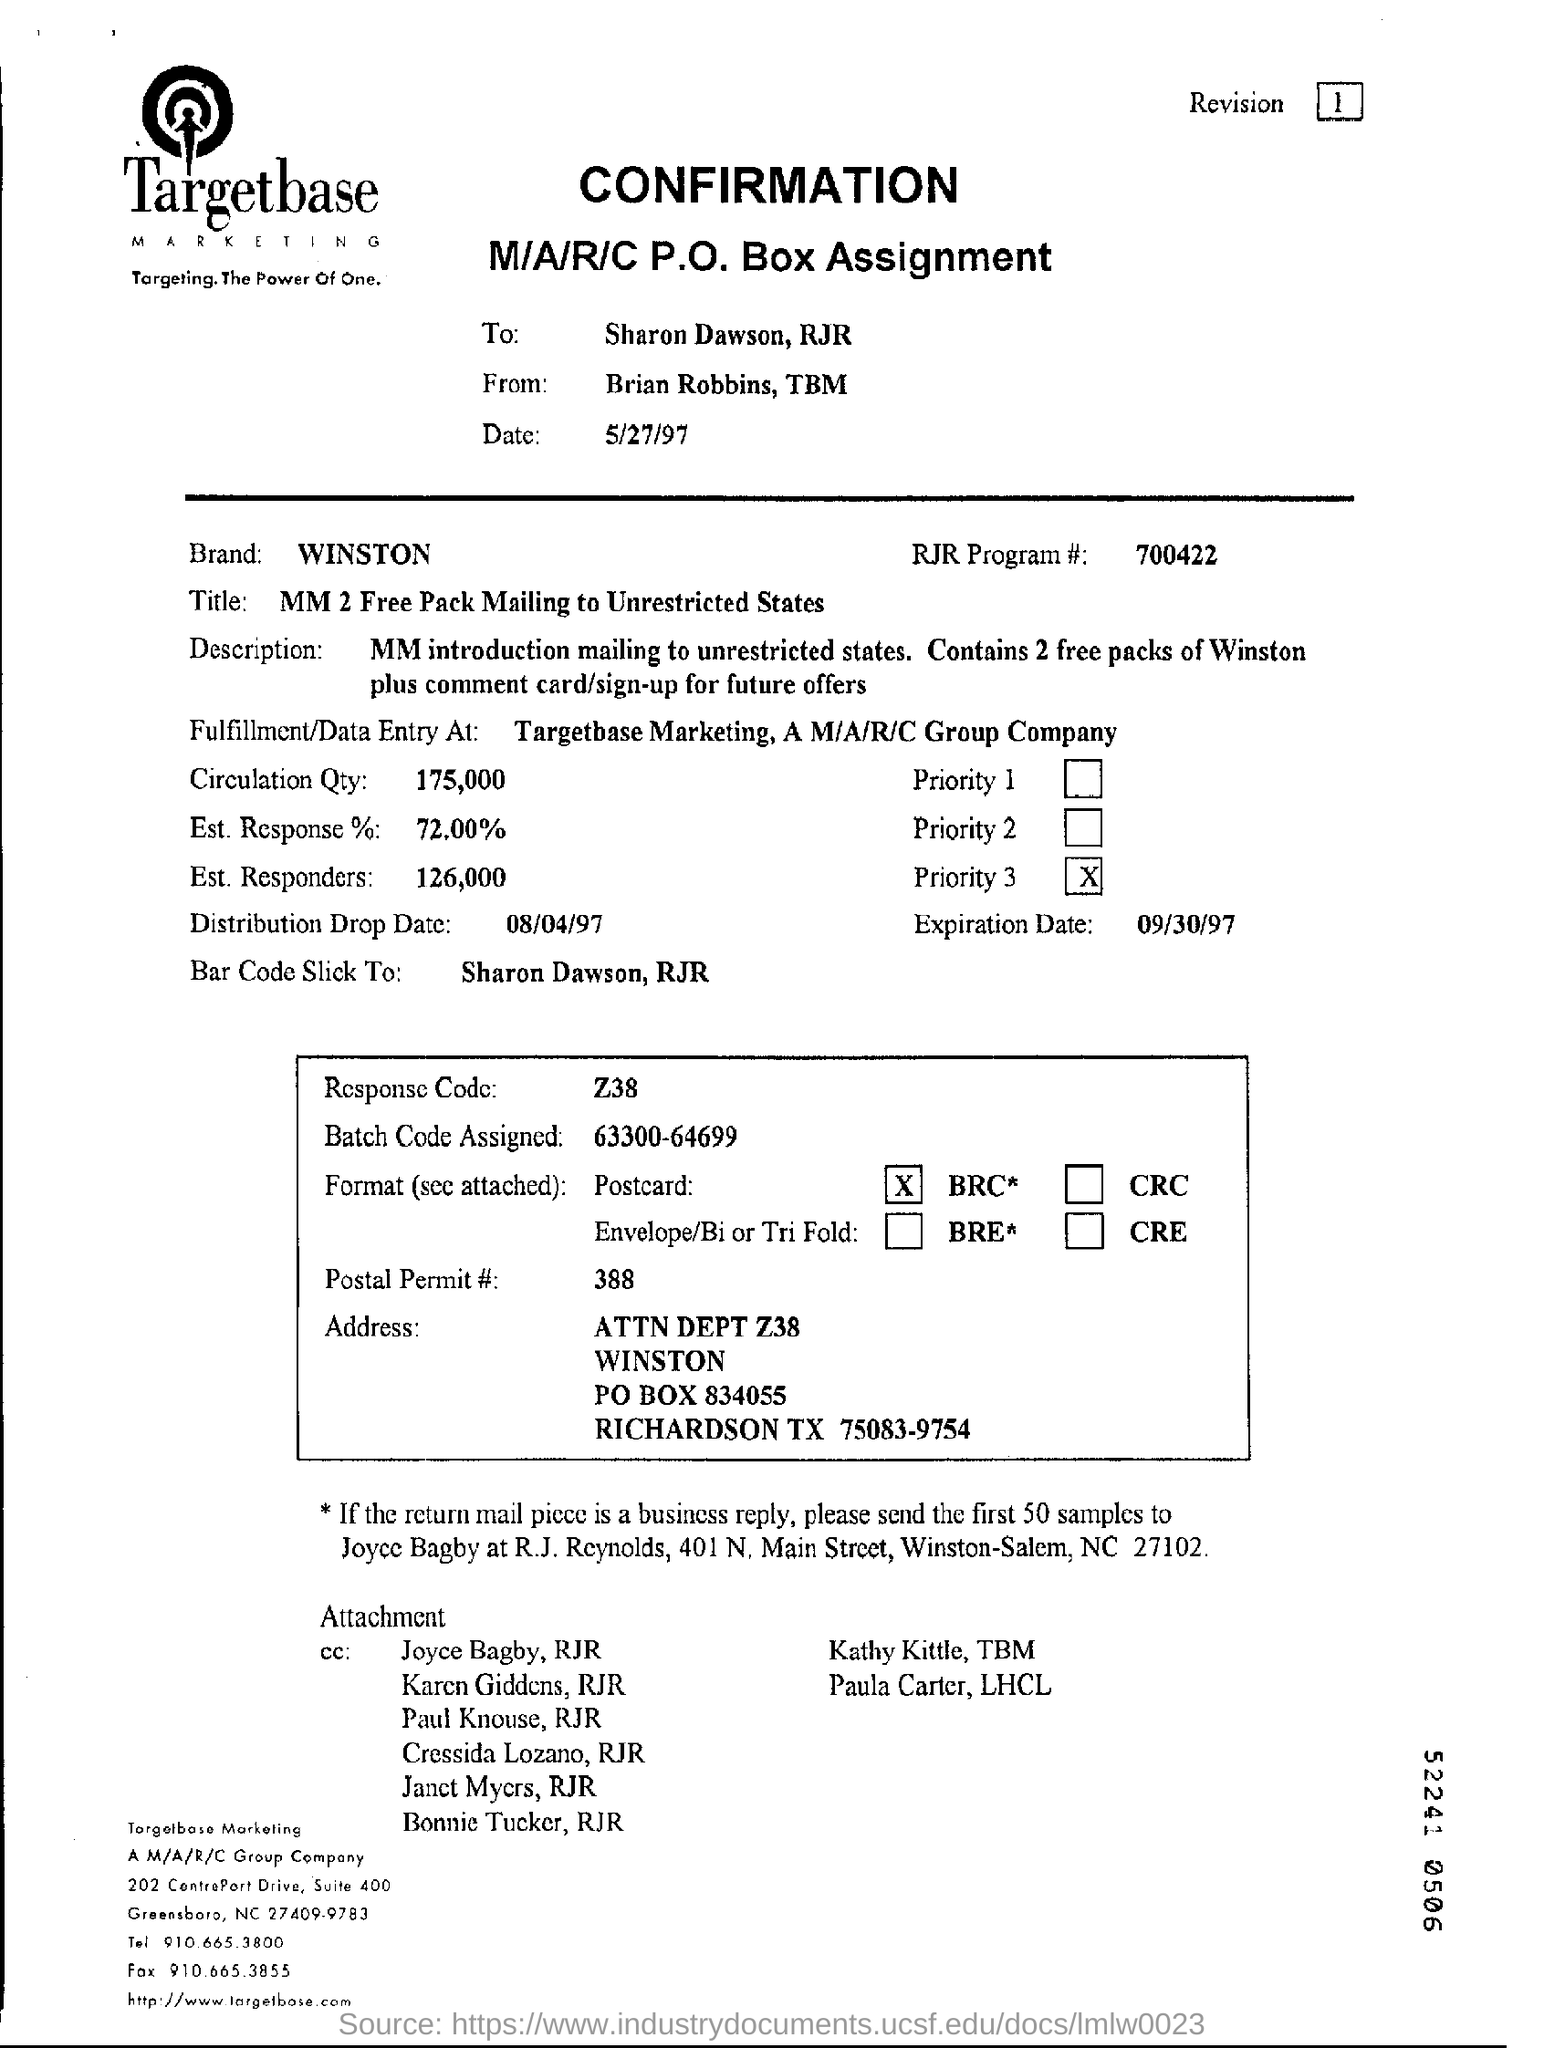What is the percentage of "Est.response" ?
Make the answer very short. 72.00. What is the quantity of circulation ?
Make the answer very short. 175,000. What is the date of confirmation ?
Provide a short and direct response. 5/27/97. What is the response code?
Give a very brief answer. Z38. What is the expiration date?
Offer a terse response. 09/30/97. 